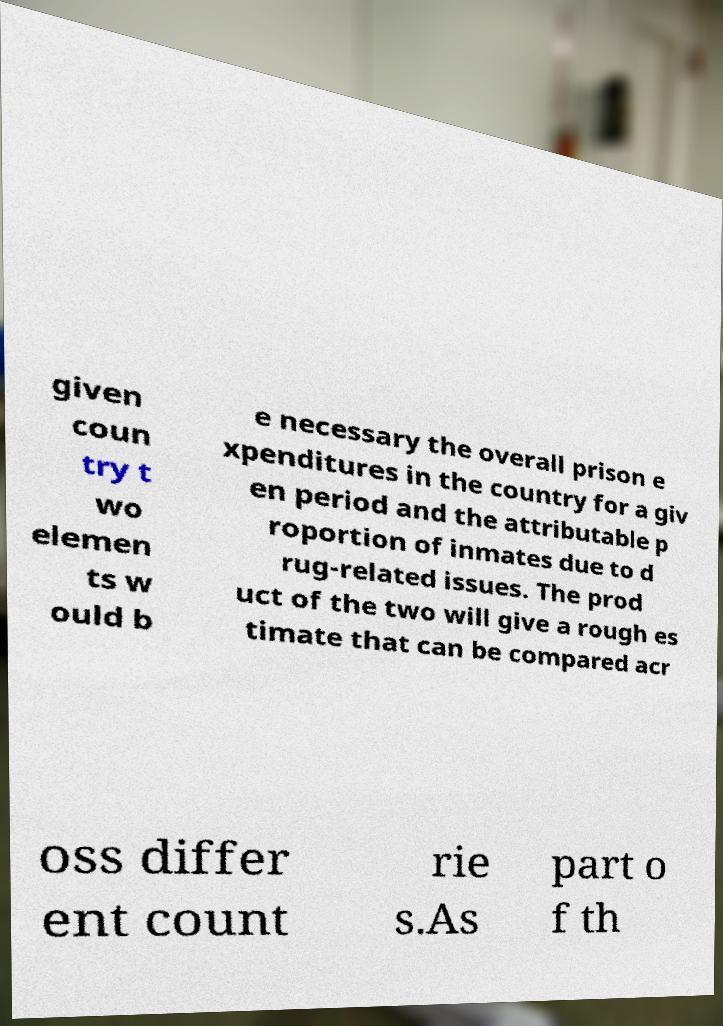Could you extract and type out the text from this image? given coun try t wo elemen ts w ould b e necessary the overall prison e xpenditures in the country for a giv en period and the attributable p roportion of inmates due to d rug-related issues. The prod uct of the two will give a rough es timate that can be compared acr oss differ ent count rie s.As part o f th 